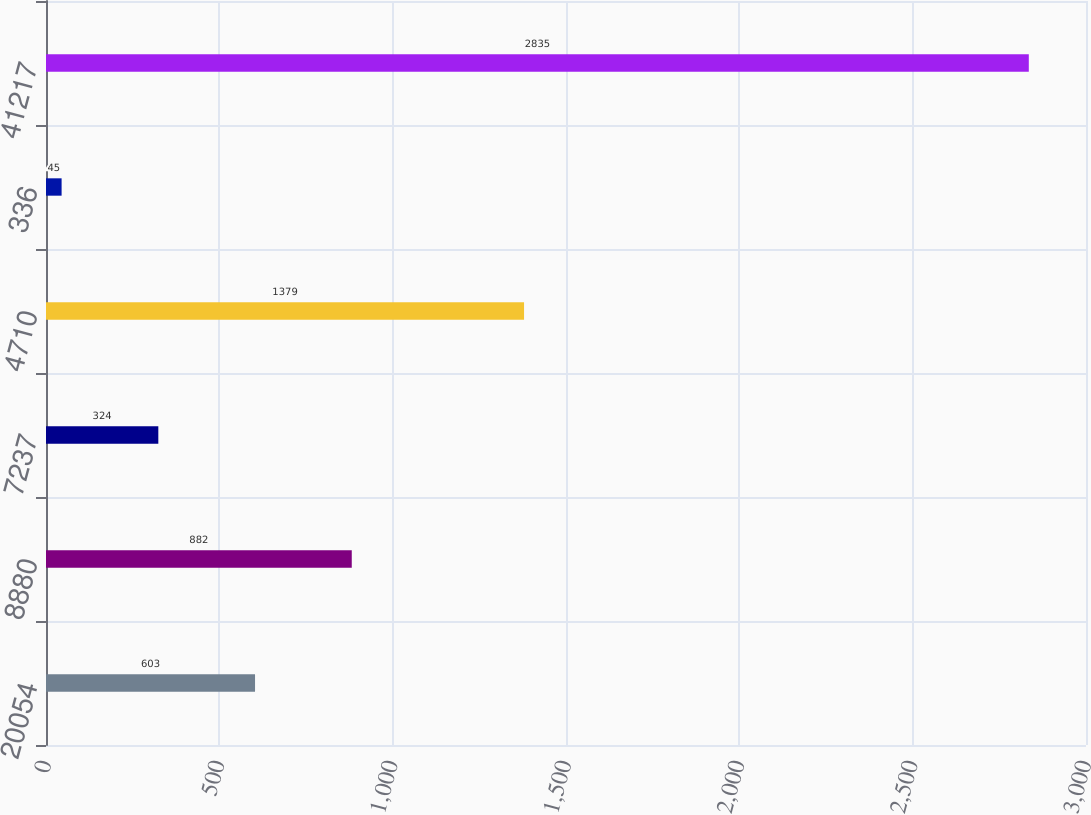<chart> <loc_0><loc_0><loc_500><loc_500><bar_chart><fcel>20054<fcel>8880<fcel>7237<fcel>4710<fcel>336<fcel>41217<nl><fcel>603<fcel>882<fcel>324<fcel>1379<fcel>45<fcel>2835<nl></chart> 